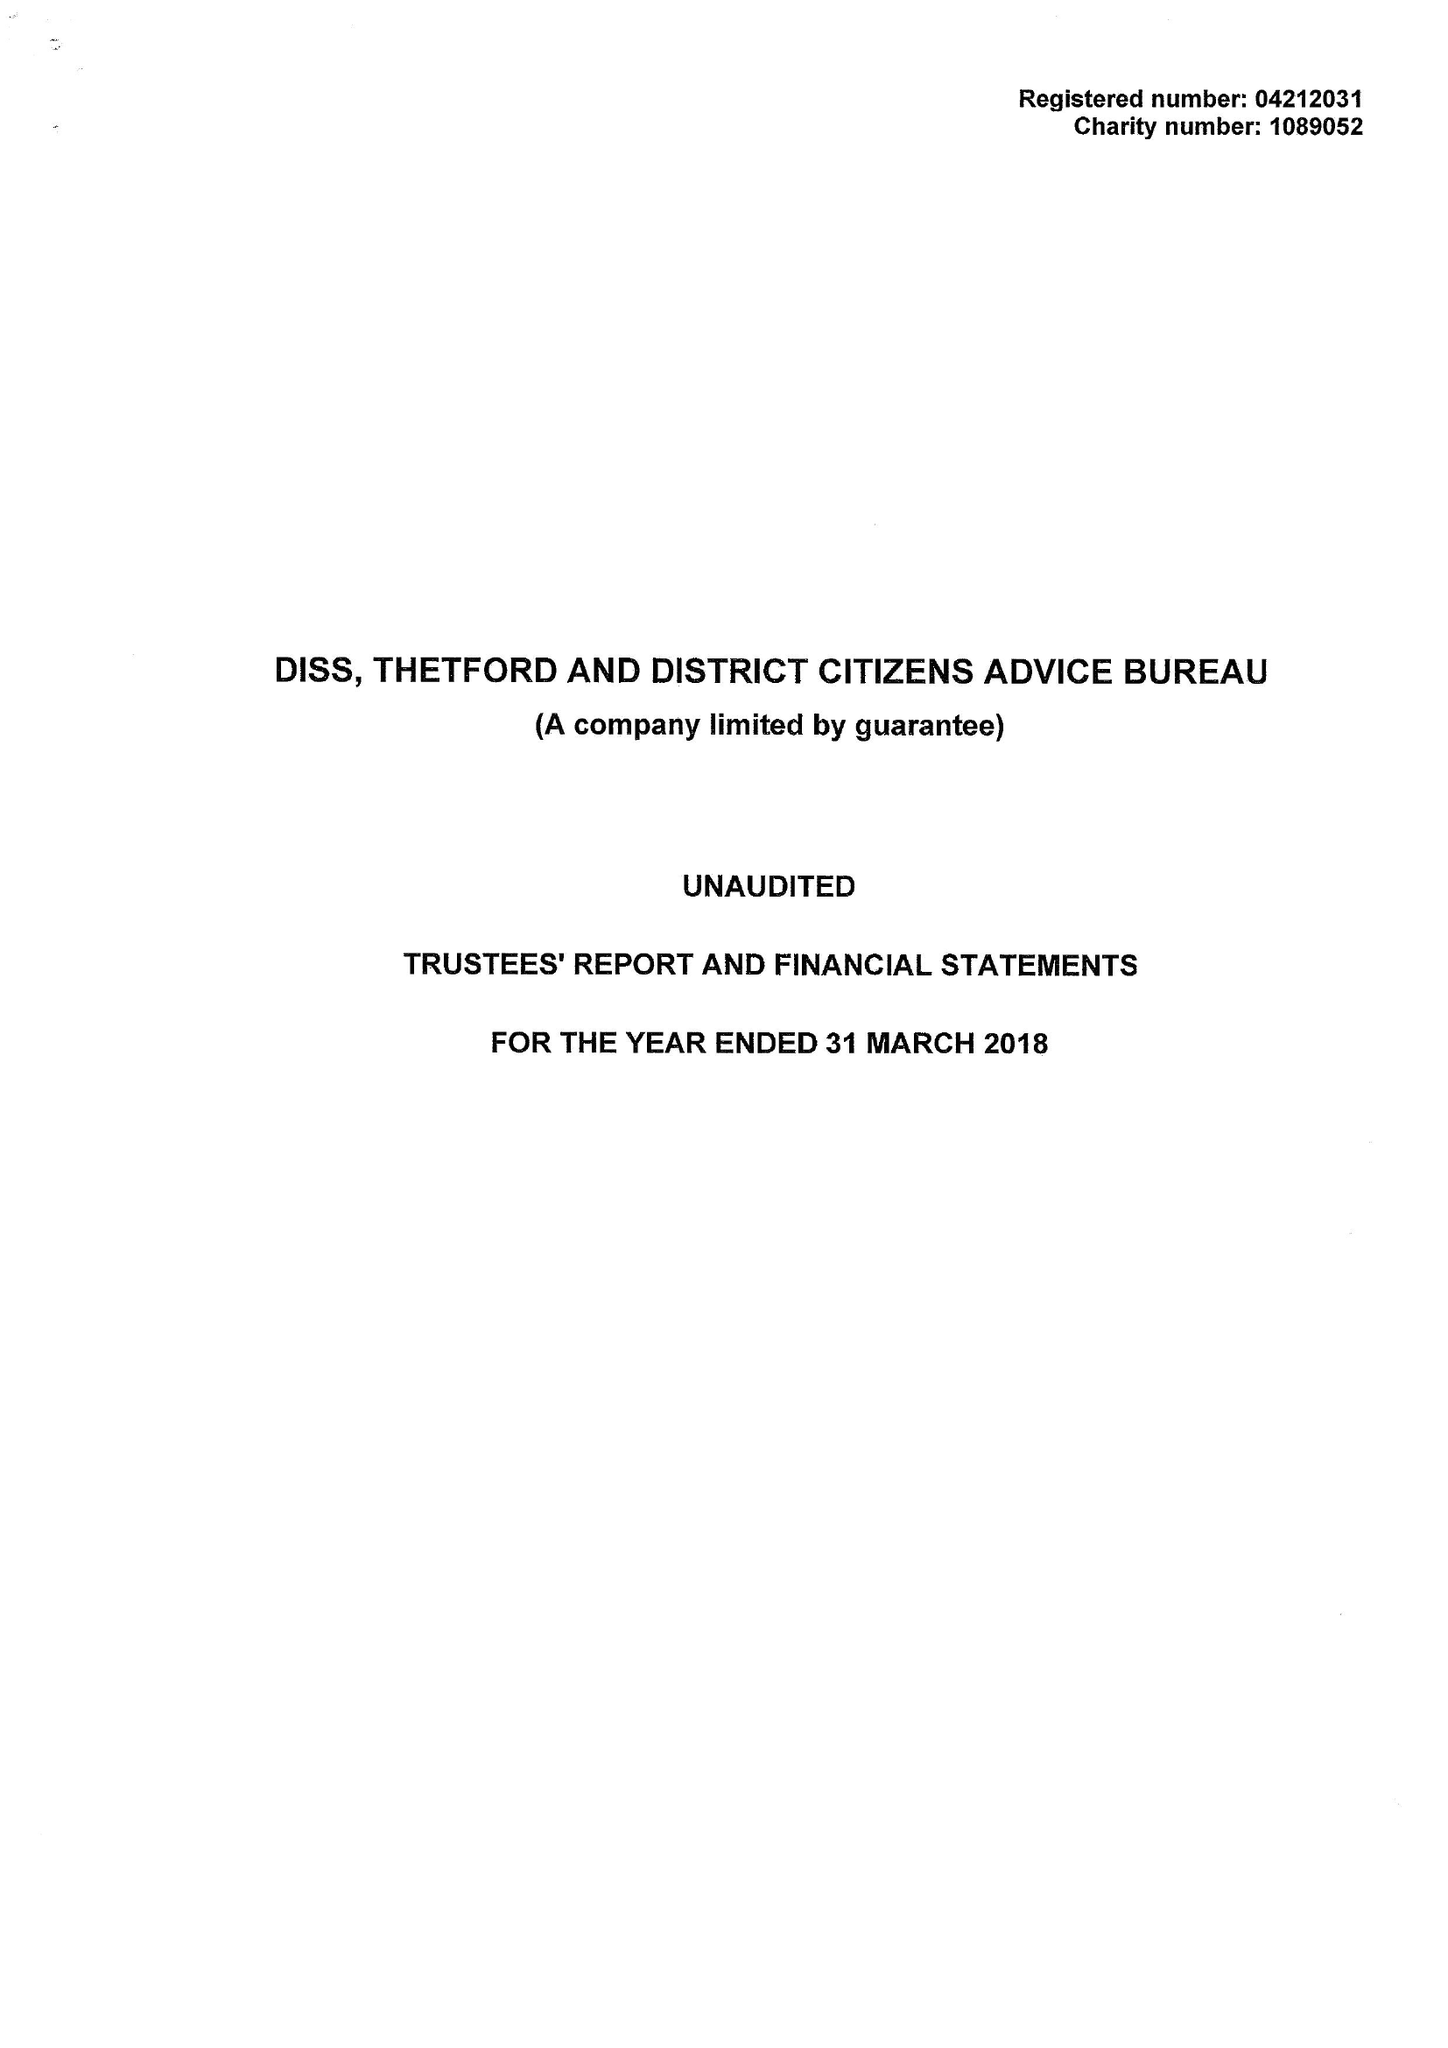What is the value for the address__post_town?
Answer the question using a single word or phrase. DISS 